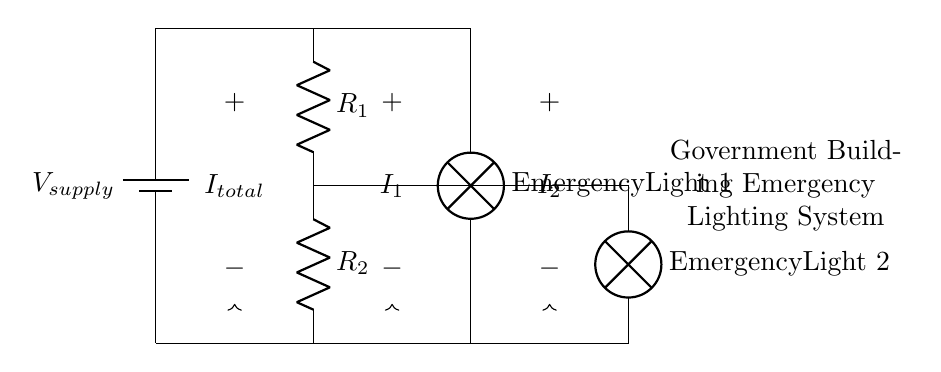What is the total current entering the circuit? The total current is denoted as I_total and can be visualized at the point where it enters the circuit from the voltage source.
Answer: I_total What are the resistances in the circuit? The resistances are labeled as R_1 and R_2. Each resistor's symbol in the diagram identifies them clearly.
Answer: R_1 and R_2 Which component receives the current from R_1? The component that receives current from R_1 is labeled as Emergency Light 2, which is directly connected to R_1.
Answer: Emergency Light 2 How is the current divided between the lamps? The current is divided according to the resistance values R_1 and R_2, with the formula I_1 = (R_2 / (R_1 + R_2)) * I_total and I_2 = (R_1 / (R_1 + R_2)) * I_total showing the distribution of current based on resistance.
Answer: According to resistance values What is the role of the lamps in the circuit? The lamps act as loads in the circuit, where each lamp converts electrical energy from the current into light energy, indicating proper functioning of the emergency lighting system.
Answer: Loads for light What happens if one lamp fails? If one lamp fails, the current through that lamp would drop to zero, but current would continue to flow through the other lamp, depending on its resistance and connection.
Answer: One lamp dims or goes out 